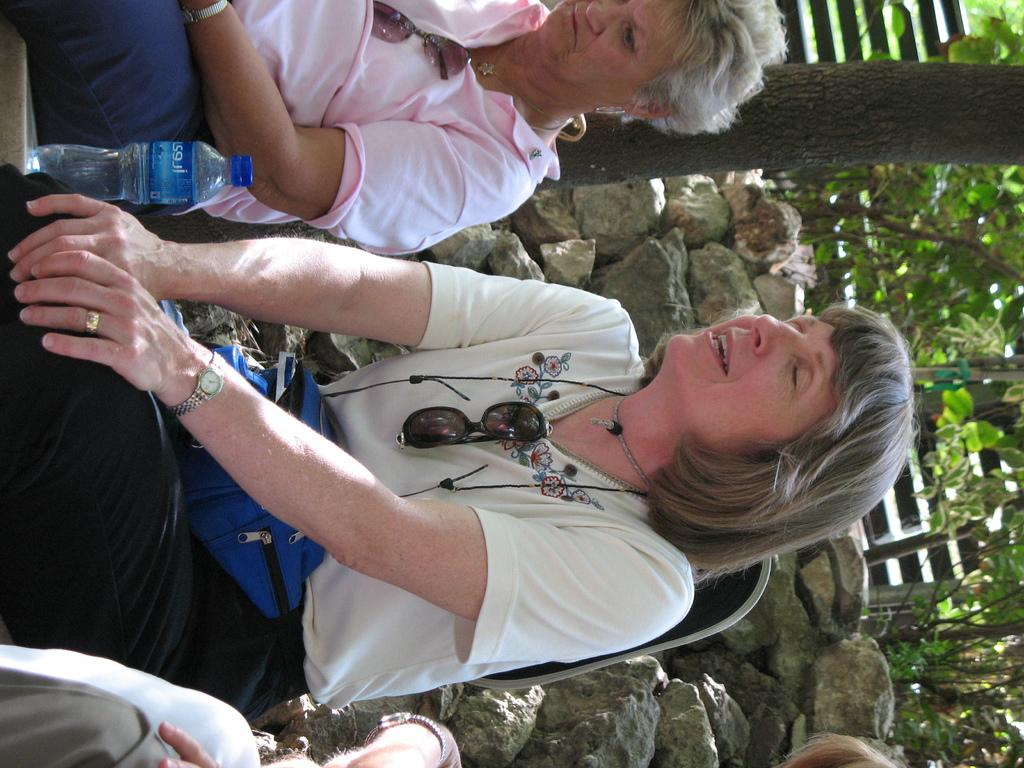What are the people in the image doing? The people in the image are sitting. What object can be seen in the image besides the people? There is a bottle in the image. What can be seen in the background of the image? There are rocks, trees, and a fence in the background of the image. What is the price of the door in the image? There is no door present in the image, so it is not possible to determine its price. 